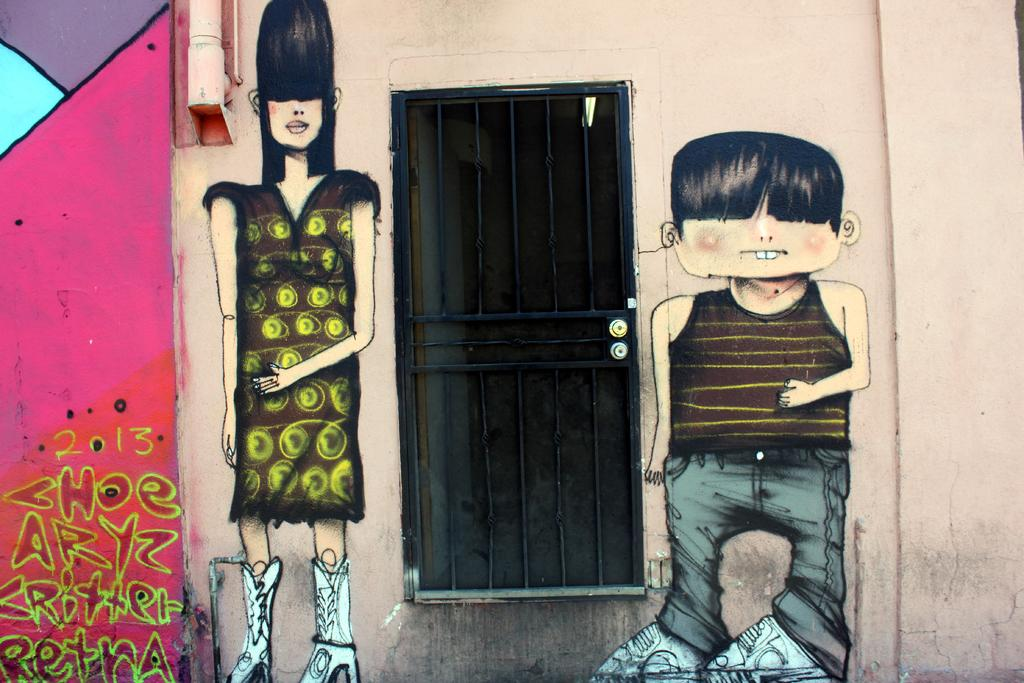What is the main subject of the image? The main subject of the image is a building. What can be seen on the wall inside the building? There is a painting of a man and woman on the wall. What else is on the wall in the image? There is a pipe on the wall. Can you see any openings in the building? Yes, there is a window in the image. What type of oven can be seen in the image? There is no oven present in the image; it features a building with a painting, pipe, and window. Can you tell me how many skateboards are visible in the image? There are no skateboards present in the image. 